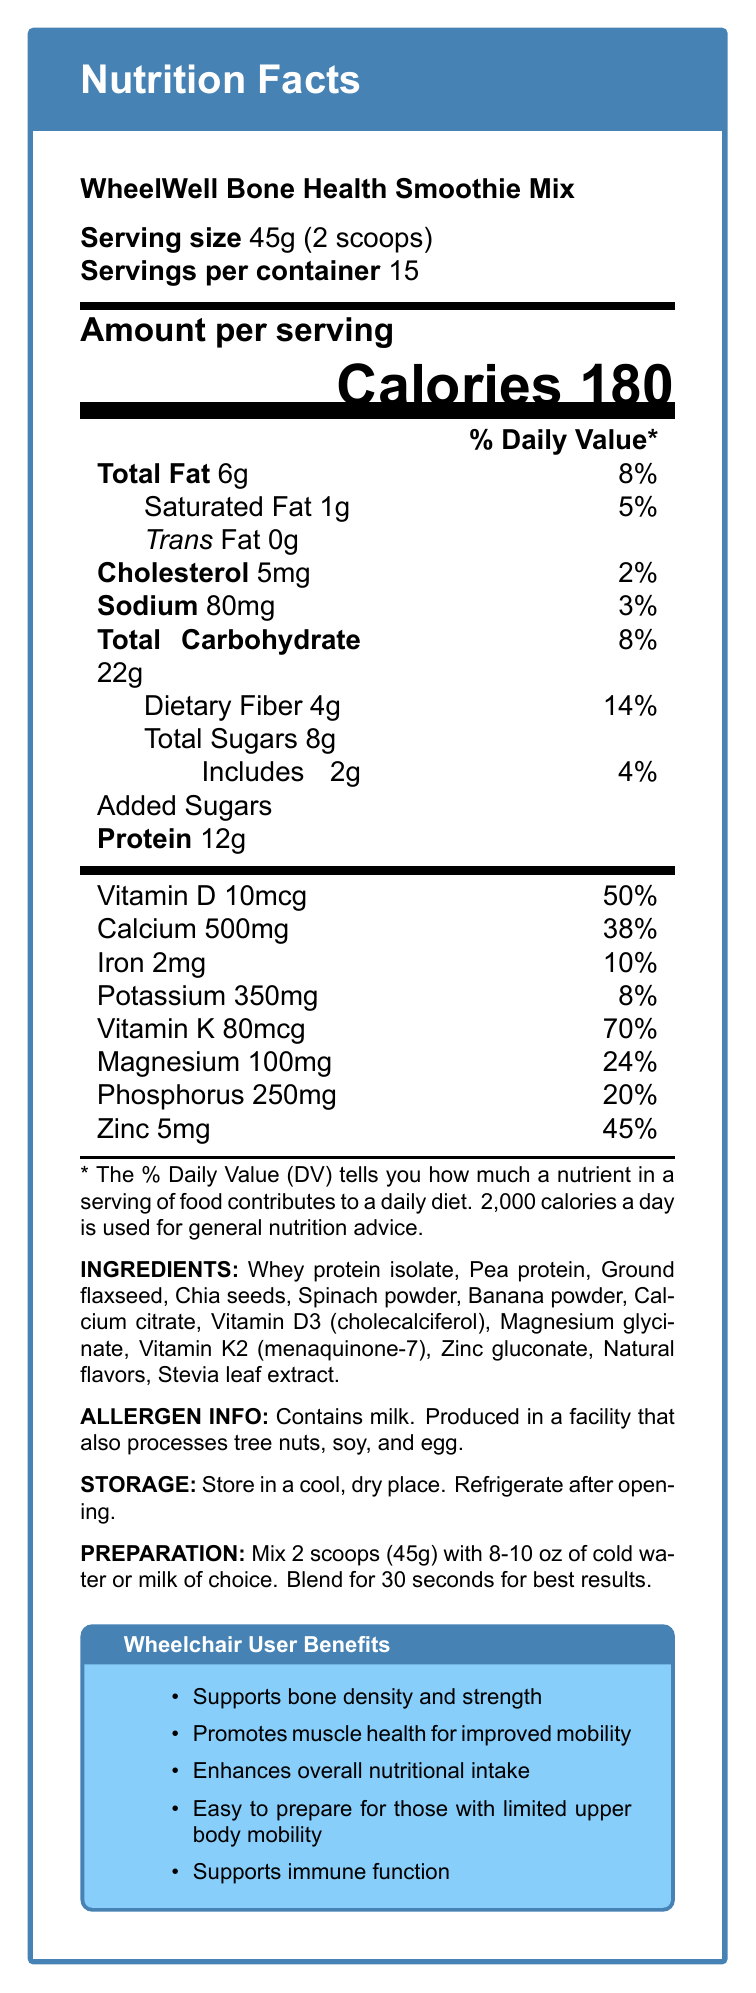which nutrient has the highest % Daily Value (DV) in a serving? The document shows that Vitamin K has a % Daily Value of 70%, which is the highest among the listed nutrients.
Answer: Vitamin K how many grams of protein are in one serving? The document lists the amount of protein per serving as 12 grams.
Answer: 12g what is the serving size for this smoothie mix? The serving size is mentioned as 45 grams, which is equivalent to 2 scoops.
Answer: 45g (2 scoops) what are the main ingredients in the WheelWell Bone Health Smoothie Mix? The ingredients are listed in the document under the INGREDIENTS section.
Answer: Whey protein isolate, Pea protein, Ground flaxseed, Chia seeds, Spinach powder, Banana powder, Calcium citrate, Vitamin D3 (cholecalciferol), Magnesium glycinate, Vitamin K2 (menaquinone-7), Zinc gluconate, Natural flavors, Stevia leaf extract how many calories are in one serving? The document specifies that each serving contains 180 calories.
Answer: 180 calories does this product contain added sugars? The document indicates that each serving includes 2 grams of added sugars.
Answer: Yes which of the following nutrients are listed with their % Daily Value (DV) amounts? (A) Vitamin D (B) Calcium (C) Sugars (D) Fiber The document lists the % Daily Value for Vitamin D, Calcium, and Dietary Fiber, but not for Sugars.
Answer: A, B, D what is the % Daily Value for calcium in one serving? (A) 24% (B) 14% (C) 38% (D) 50% The % Daily Value for calcium is listed as 38%.
Answer: C does the document mention that the product is beneficial for muscle health and mobility? The benefits section for wheelchair users states that the product promotes muscle health for improved mobility.
Answer: Yes is this product safe for someone with a tree nut allergy? The document states that the product is produced in a facility that also processes tree nuts, but it does not specify the risk for someone with a tree nut allergy.
Answer: Not enough information summarize the main nutritional benefits of the WheelWell Bone Health Smoothie Mix as described in the document. The document lists multiple benefits for wheelchair users and details the nutritional content that supports these benefits, including high amounts of essential vitamins and minerals.
Answer: The WheelWell Bone Health Smoothie Mix provides significant benefits for bone density and strength, muscle health, overall nutritional intake, ease of preparation for those with limited mobility, and supports immune function. It is nutrient-dense with substantial amounts of protein, vitamins D and K, calcium, magnesium, phosphorus, and zinc. 